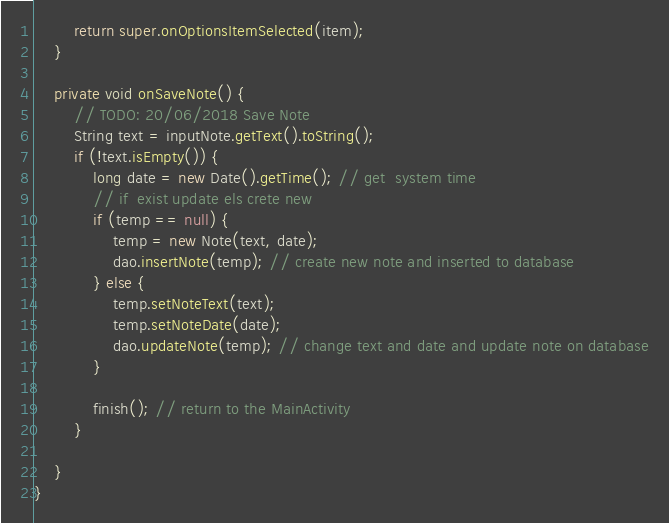<code> <loc_0><loc_0><loc_500><loc_500><_Java_>        return super.onOptionsItemSelected(item);
    }

    private void onSaveNote() {
        // TODO: 20/06/2018 Save Note
        String text = inputNote.getText().toString();
        if (!text.isEmpty()) {
            long date = new Date().getTime(); // get  system time
            // if  exist update els crete new
            if (temp == null) {
                temp = new Note(text, date);
                dao.insertNote(temp); // create new note and inserted to database
            } else {
                temp.setNoteText(text);
                temp.setNoteDate(date);
                dao.updateNote(temp); // change text and date and update note on database
            }

            finish(); // return to the MainActivity
        }

    }
}
</code> 